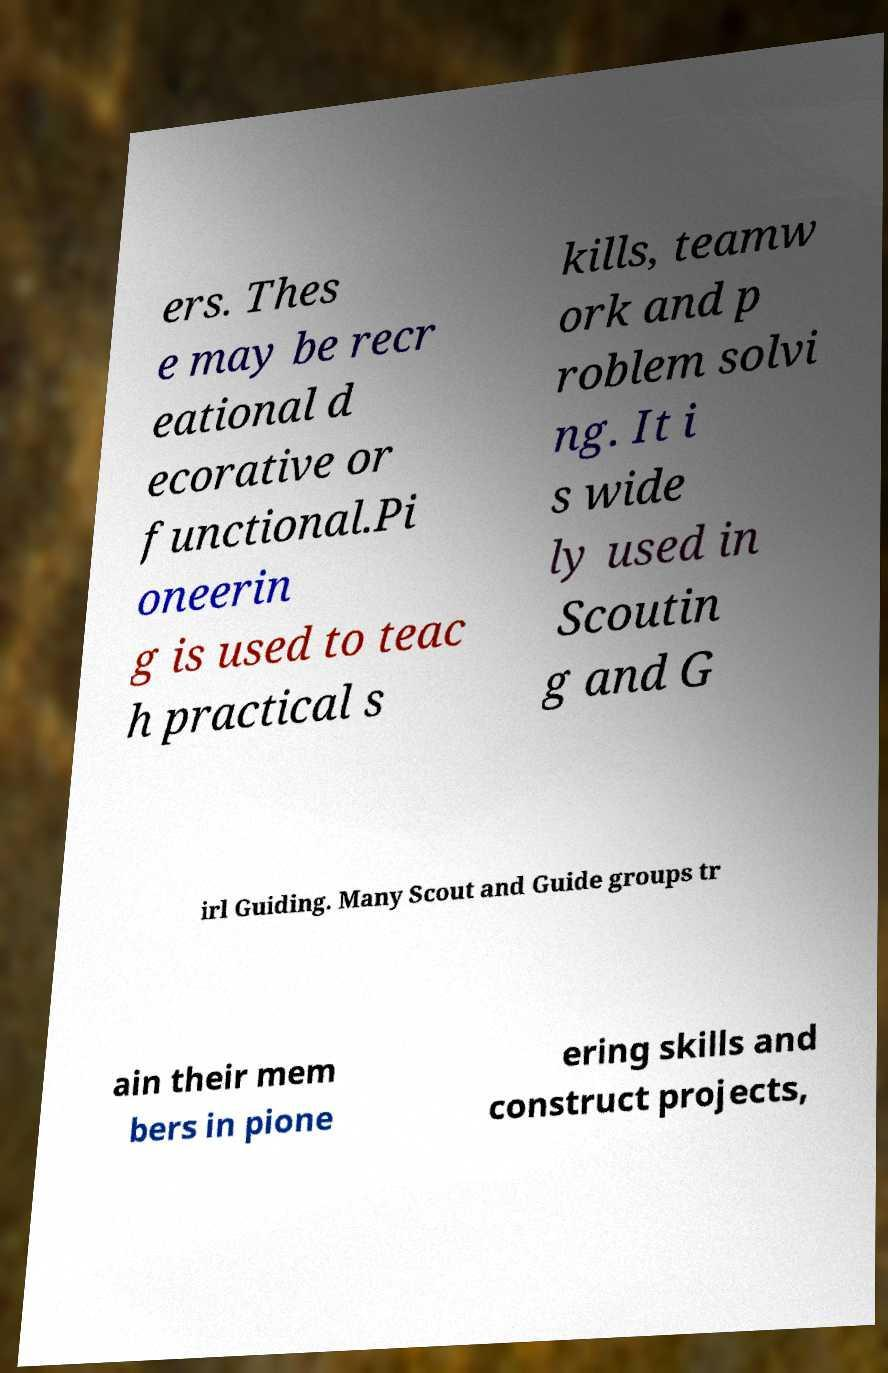For documentation purposes, I need the text within this image transcribed. Could you provide that? ers. Thes e may be recr eational d ecorative or functional.Pi oneerin g is used to teac h practical s kills, teamw ork and p roblem solvi ng. It i s wide ly used in Scoutin g and G irl Guiding. Many Scout and Guide groups tr ain their mem bers in pione ering skills and construct projects, 